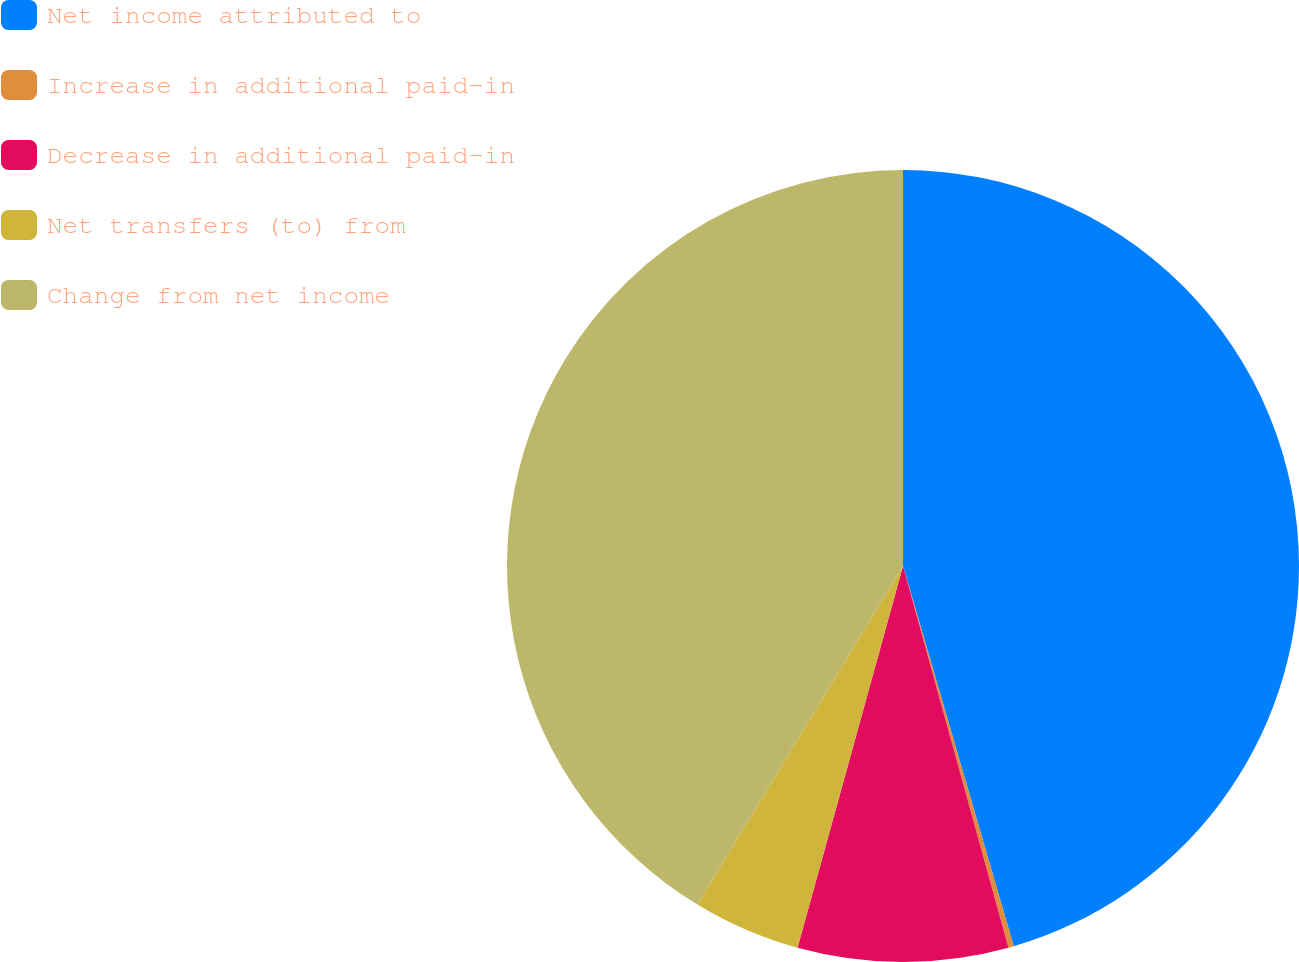Convert chart. <chart><loc_0><loc_0><loc_500><loc_500><pie_chart><fcel>Net income attributed to<fcel>Increase in additional paid-in<fcel>Decrease in additional paid-in<fcel>Net transfers (to) from<fcel>Change from net income<nl><fcel>45.49%<fcel>0.22%<fcel>8.58%<fcel>4.4%<fcel>41.31%<nl></chart> 